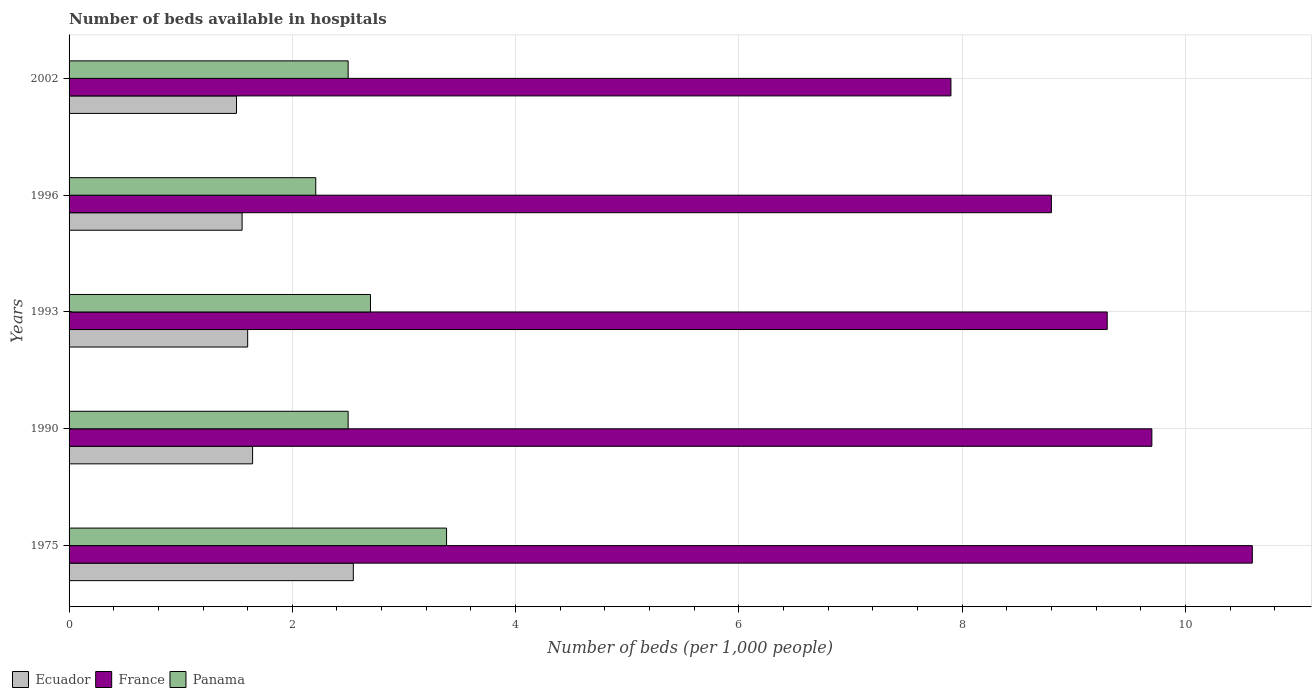How many groups of bars are there?
Ensure brevity in your answer.  5. Are the number of bars per tick equal to the number of legend labels?
Make the answer very short. Yes. How many bars are there on the 2nd tick from the top?
Your response must be concise. 3. What is the label of the 5th group of bars from the top?
Your response must be concise. 1975. In how many cases, is the number of bars for a given year not equal to the number of legend labels?
Your response must be concise. 0. What is the number of beds in the hospiatls of in France in 2002?
Make the answer very short. 7.9. Across all years, what is the maximum number of beds in the hospiatls of in France?
Offer a very short reply. 10.6. Across all years, what is the minimum number of beds in the hospiatls of in Ecuador?
Offer a very short reply. 1.5. In which year was the number of beds in the hospiatls of in Panama maximum?
Your response must be concise. 1975. What is the total number of beds in the hospiatls of in France in the graph?
Give a very brief answer. 46.3. What is the difference between the number of beds in the hospiatls of in France in 1975 and that in 1993?
Your response must be concise. 1.3. What is the difference between the number of beds in the hospiatls of in Ecuador in 1993 and the number of beds in the hospiatls of in France in 1996?
Keep it short and to the point. -7.2. What is the average number of beds in the hospiatls of in Ecuador per year?
Provide a succinct answer. 1.77. In the year 1975, what is the difference between the number of beds in the hospiatls of in Ecuador and number of beds in the hospiatls of in Panama?
Make the answer very short. -0.84. In how many years, is the number of beds in the hospiatls of in Ecuador greater than 6 ?
Your answer should be very brief. 0. What is the ratio of the number of beds in the hospiatls of in France in 1993 to that in 2002?
Provide a succinct answer. 1.18. Is the number of beds in the hospiatls of in Panama in 1990 less than that in 2002?
Make the answer very short. No. Is the difference between the number of beds in the hospiatls of in Ecuador in 1975 and 2002 greater than the difference between the number of beds in the hospiatls of in Panama in 1975 and 2002?
Provide a short and direct response. Yes. What is the difference between the highest and the second highest number of beds in the hospiatls of in France?
Provide a succinct answer. 0.9. What is the difference between the highest and the lowest number of beds in the hospiatls of in Ecuador?
Give a very brief answer. 1.05. What does the 3rd bar from the top in 1990 represents?
Your answer should be compact. Ecuador. What does the 3rd bar from the bottom in 1996 represents?
Offer a very short reply. Panama. Is it the case that in every year, the sum of the number of beds in the hospiatls of in Ecuador and number of beds in the hospiatls of in France is greater than the number of beds in the hospiatls of in Panama?
Offer a terse response. Yes. How many bars are there?
Your answer should be compact. 15. Are all the bars in the graph horizontal?
Your response must be concise. Yes. How many years are there in the graph?
Offer a terse response. 5. What is the difference between two consecutive major ticks on the X-axis?
Your answer should be very brief. 2. Where does the legend appear in the graph?
Your answer should be compact. Bottom left. What is the title of the graph?
Your answer should be very brief. Number of beds available in hospitals. Does "Seychelles" appear as one of the legend labels in the graph?
Give a very brief answer. No. What is the label or title of the X-axis?
Offer a very short reply. Number of beds (per 1,0 people). What is the label or title of the Y-axis?
Keep it short and to the point. Years. What is the Number of beds (per 1,000 people) of Ecuador in 1975?
Make the answer very short. 2.55. What is the Number of beds (per 1,000 people) of France in 1975?
Provide a succinct answer. 10.6. What is the Number of beds (per 1,000 people) of Panama in 1975?
Offer a very short reply. 3.38. What is the Number of beds (per 1,000 people) in Ecuador in 1990?
Give a very brief answer. 1.64. What is the Number of beds (per 1,000 people) of France in 1990?
Ensure brevity in your answer.  9.7. What is the Number of beds (per 1,000 people) of Ecuador in 1993?
Offer a terse response. 1.6. What is the Number of beds (per 1,000 people) of France in 1993?
Keep it short and to the point. 9.3. What is the Number of beds (per 1,000 people) in Panama in 1993?
Provide a short and direct response. 2.7. What is the Number of beds (per 1,000 people) of Ecuador in 1996?
Provide a short and direct response. 1.55. What is the Number of beds (per 1,000 people) in France in 1996?
Ensure brevity in your answer.  8.8. What is the Number of beds (per 1,000 people) of Panama in 1996?
Make the answer very short. 2.21. What is the Number of beds (per 1,000 people) in Ecuador in 2002?
Ensure brevity in your answer.  1.5. What is the Number of beds (per 1,000 people) of France in 2002?
Make the answer very short. 7.9. Across all years, what is the maximum Number of beds (per 1,000 people) in Ecuador?
Provide a short and direct response. 2.55. Across all years, what is the maximum Number of beds (per 1,000 people) of France?
Give a very brief answer. 10.6. Across all years, what is the maximum Number of beds (per 1,000 people) of Panama?
Give a very brief answer. 3.38. Across all years, what is the minimum Number of beds (per 1,000 people) in Ecuador?
Keep it short and to the point. 1.5. Across all years, what is the minimum Number of beds (per 1,000 people) of France?
Your response must be concise. 7.9. Across all years, what is the minimum Number of beds (per 1,000 people) in Panama?
Keep it short and to the point. 2.21. What is the total Number of beds (per 1,000 people) in Ecuador in the graph?
Give a very brief answer. 8.84. What is the total Number of beds (per 1,000 people) of France in the graph?
Keep it short and to the point. 46.3. What is the total Number of beds (per 1,000 people) of Panama in the graph?
Offer a very short reply. 13.29. What is the difference between the Number of beds (per 1,000 people) of Ecuador in 1975 and that in 1990?
Give a very brief answer. 0.9. What is the difference between the Number of beds (per 1,000 people) in France in 1975 and that in 1990?
Give a very brief answer. 0.9. What is the difference between the Number of beds (per 1,000 people) in Panama in 1975 and that in 1990?
Make the answer very short. 0.88. What is the difference between the Number of beds (per 1,000 people) in Ecuador in 1975 and that in 1993?
Give a very brief answer. 0.95. What is the difference between the Number of beds (per 1,000 people) in France in 1975 and that in 1993?
Ensure brevity in your answer.  1.3. What is the difference between the Number of beds (per 1,000 people) in Panama in 1975 and that in 1993?
Provide a succinct answer. 0.68. What is the difference between the Number of beds (per 1,000 people) in Ecuador in 1975 and that in 1996?
Give a very brief answer. 1. What is the difference between the Number of beds (per 1,000 people) in Panama in 1975 and that in 1996?
Offer a terse response. 1.17. What is the difference between the Number of beds (per 1,000 people) of Ecuador in 1975 and that in 2002?
Provide a short and direct response. 1.05. What is the difference between the Number of beds (per 1,000 people) in France in 1975 and that in 2002?
Ensure brevity in your answer.  2.7. What is the difference between the Number of beds (per 1,000 people) of Panama in 1975 and that in 2002?
Offer a very short reply. 0.88. What is the difference between the Number of beds (per 1,000 people) of Ecuador in 1990 and that in 1993?
Offer a very short reply. 0.04. What is the difference between the Number of beds (per 1,000 people) of Ecuador in 1990 and that in 1996?
Ensure brevity in your answer.  0.09. What is the difference between the Number of beds (per 1,000 people) of Panama in 1990 and that in 1996?
Offer a very short reply. 0.29. What is the difference between the Number of beds (per 1,000 people) of Ecuador in 1990 and that in 2002?
Offer a very short reply. 0.14. What is the difference between the Number of beds (per 1,000 people) in France in 1993 and that in 1996?
Make the answer very short. 0.5. What is the difference between the Number of beds (per 1,000 people) of Panama in 1993 and that in 1996?
Your response must be concise. 0.49. What is the difference between the Number of beds (per 1,000 people) of Ecuador in 1993 and that in 2002?
Your answer should be very brief. 0.1. What is the difference between the Number of beds (per 1,000 people) of France in 1993 and that in 2002?
Your response must be concise. 1.4. What is the difference between the Number of beds (per 1,000 people) in France in 1996 and that in 2002?
Provide a succinct answer. 0.9. What is the difference between the Number of beds (per 1,000 people) of Panama in 1996 and that in 2002?
Your answer should be very brief. -0.29. What is the difference between the Number of beds (per 1,000 people) in Ecuador in 1975 and the Number of beds (per 1,000 people) in France in 1990?
Ensure brevity in your answer.  -7.15. What is the difference between the Number of beds (per 1,000 people) of Ecuador in 1975 and the Number of beds (per 1,000 people) of Panama in 1990?
Your answer should be very brief. 0.05. What is the difference between the Number of beds (per 1,000 people) of Ecuador in 1975 and the Number of beds (per 1,000 people) of France in 1993?
Your answer should be very brief. -6.75. What is the difference between the Number of beds (per 1,000 people) of Ecuador in 1975 and the Number of beds (per 1,000 people) of Panama in 1993?
Give a very brief answer. -0.15. What is the difference between the Number of beds (per 1,000 people) in France in 1975 and the Number of beds (per 1,000 people) in Panama in 1993?
Give a very brief answer. 7.9. What is the difference between the Number of beds (per 1,000 people) in Ecuador in 1975 and the Number of beds (per 1,000 people) in France in 1996?
Offer a terse response. -6.25. What is the difference between the Number of beds (per 1,000 people) of Ecuador in 1975 and the Number of beds (per 1,000 people) of Panama in 1996?
Make the answer very short. 0.34. What is the difference between the Number of beds (per 1,000 people) of France in 1975 and the Number of beds (per 1,000 people) of Panama in 1996?
Your response must be concise. 8.39. What is the difference between the Number of beds (per 1,000 people) in Ecuador in 1975 and the Number of beds (per 1,000 people) in France in 2002?
Provide a short and direct response. -5.35. What is the difference between the Number of beds (per 1,000 people) in Ecuador in 1975 and the Number of beds (per 1,000 people) in Panama in 2002?
Your answer should be very brief. 0.05. What is the difference between the Number of beds (per 1,000 people) of Ecuador in 1990 and the Number of beds (per 1,000 people) of France in 1993?
Provide a short and direct response. -7.66. What is the difference between the Number of beds (per 1,000 people) of Ecuador in 1990 and the Number of beds (per 1,000 people) of Panama in 1993?
Offer a terse response. -1.06. What is the difference between the Number of beds (per 1,000 people) of France in 1990 and the Number of beds (per 1,000 people) of Panama in 1993?
Give a very brief answer. 7. What is the difference between the Number of beds (per 1,000 people) of Ecuador in 1990 and the Number of beds (per 1,000 people) of France in 1996?
Your answer should be very brief. -7.16. What is the difference between the Number of beds (per 1,000 people) in Ecuador in 1990 and the Number of beds (per 1,000 people) in Panama in 1996?
Your answer should be very brief. -0.57. What is the difference between the Number of beds (per 1,000 people) in France in 1990 and the Number of beds (per 1,000 people) in Panama in 1996?
Your answer should be compact. 7.49. What is the difference between the Number of beds (per 1,000 people) of Ecuador in 1990 and the Number of beds (per 1,000 people) of France in 2002?
Ensure brevity in your answer.  -6.26. What is the difference between the Number of beds (per 1,000 people) of Ecuador in 1990 and the Number of beds (per 1,000 people) of Panama in 2002?
Offer a very short reply. -0.86. What is the difference between the Number of beds (per 1,000 people) in Ecuador in 1993 and the Number of beds (per 1,000 people) in Panama in 1996?
Keep it short and to the point. -0.61. What is the difference between the Number of beds (per 1,000 people) in France in 1993 and the Number of beds (per 1,000 people) in Panama in 1996?
Your response must be concise. 7.09. What is the difference between the Number of beds (per 1,000 people) in France in 1993 and the Number of beds (per 1,000 people) in Panama in 2002?
Give a very brief answer. 6.8. What is the difference between the Number of beds (per 1,000 people) of Ecuador in 1996 and the Number of beds (per 1,000 people) of France in 2002?
Offer a terse response. -6.35. What is the difference between the Number of beds (per 1,000 people) of Ecuador in 1996 and the Number of beds (per 1,000 people) of Panama in 2002?
Keep it short and to the point. -0.95. What is the difference between the Number of beds (per 1,000 people) in France in 1996 and the Number of beds (per 1,000 people) in Panama in 2002?
Your answer should be compact. 6.3. What is the average Number of beds (per 1,000 people) in Ecuador per year?
Give a very brief answer. 1.77. What is the average Number of beds (per 1,000 people) in France per year?
Provide a succinct answer. 9.26. What is the average Number of beds (per 1,000 people) in Panama per year?
Offer a terse response. 2.66. In the year 1975, what is the difference between the Number of beds (per 1,000 people) in Ecuador and Number of beds (per 1,000 people) in France?
Provide a succinct answer. -8.05. In the year 1975, what is the difference between the Number of beds (per 1,000 people) of Ecuador and Number of beds (per 1,000 people) of Panama?
Your response must be concise. -0.84. In the year 1975, what is the difference between the Number of beds (per 1,000 people) in France and Number of beds (per 1,000 people) in Panama?
Your response must be concise. 7.22. In the year 1990, what is the difference between the Number of beds (per 1,000 people) in Ecuador and Number of beds (per 1,000 people) in France?
Provide a succinct answer. -8.06. In the year 1990, what is the difference between the Number of beds (per 1,000 people) in Ecuador and Number of beds (per 1,000 people) in Panama?
Provide a short and direct response. -0.86. In the year 1990, what is the difference between the Number of beds (per 1,000 people) of France and Number of beds (per 1,000 people) of Panama?
Provide a short and direct response. 7.2. In the year 1993, what is the difference between the Number of beds (per 1,000 people) of France and Number of beds (per 1,000 people) of Panama?
Make the answer very short. 6.6. In the year 1996, what is the difference between the Number of beds (per 1,000 people) of Ecuador and Number of beds (per 1,000 people) of France?
Keep it short and to the point. -7.25. In the year 1996, what is the difference between the Number of beds (per 1,000 people) in Ecuador and Number of beds (per 1,000 people) in Panama?
Your response must be concise. -0.66. In the year 1996, what is the difference between the Number of beds (per 1,000 people) in France and Number of beds (per 1,000 people) in Panama?
Ensure brevity in your answer.  6.59. In the year 2002, what is the difference between the Number of beds (per 1,000 people) of Ecuador and Number of beds (per 1,000 people) of Panama?
Your response must be concise. -1. What is the ratio of the Number of beds (per 1,000 people) in Ecuador in 1975 to that in 1990?
Ensure brevity in your answer.  1.55. What is the ratio of the Number of beds (per 1,000 people) of France in 1975 to that in 1990?
Your answer should be very brief. 1.09. What is the ratio of the Number of beds (per 1,000 people) of Panama in 1975 to that in 1990?
Provide a succinct answer. 1.35. What is the ratio of the Number of beds (per 1,000 people) of Ecuador in 1975 to that in 1993?
Your answer should be compact. 1.59. What is the ratio of the Number of beds (per 1,000 people) of France in 1975 to that in 1993?
Keep it short and to the point. 1.14. What is the ratio of the Number of beds (per 1,000 people) of Panama in 1975 to that in 1993?
Make the answer very short. 1.25. What is the ratio of the Number of beds (per 1,000 people) of Ecuador in 1975 to that in 1996?
Your answer should be very brief. 1.64. What is the ratio of the Number of beds (per 1,000 people) in France in 1975 to that in 1996?
Your answer should be very brief. 1.2. What is the ratio of the Number of beds (per 1,000 people) in Panama in 1975 to that in 1996?
Offer a very short reply. 1.53. What is the ratio of the Number of beds (per 1,000 people) of Ecuador in 1975 to that in 2002?
Offer a very short reply. 1.7. What is the ratio of the Number of beds (per 1,000 people) in France in 1975 to that in 2002?
Your answer should be compact. 1.34. What is the ratio of the Number of beds (per 1,000 people) of Panama in 1975 to that in 2002?
Offer a terse response. 1.35. What is the ratio of the Number of beds (per 1,000 people) of Ecuador in 1990 to that in 1993?
Provide a succinct answer. 1.03. What is the ratio of the Number of beds (per 1,000 people) in France in 1990 to that in 1993?
Offer a very short reply. 1.04. What is the ratio of the Number of beds (per 1,000 people) of Panama in 1990 to that in 1993?
Provide a succinct answer. 0.93. What is the ratio of the Number of beds (per 1,000 people) of Ecuador in 1990 to that in 1996?
Your answer should be compact. 1.06. What is the ratio of the Number of beds (per 1,000 people) in France in 1990 to that in 1996?
Make the answer very short. 1.1. What is the ratio of the Number of beds (per 1,000 people) in Panama in 1990 to that in 1996?
Your response must be concise. 1.13. What is the ratio of the Number of beds (per 1,000 people) of Ecuador in 1990 to that in 2002?
Ensure brevity in your answer.  1.1. What is the ratio of the Number of beds (per 1,000 people) of France in 1990 to that in 2002?
Provide a short and direct response. 1.23. What is the ratio of the Number of beds (per 1,000 people) in Ecuador in 1993 to that in 1996?
Offer a terse response. 1.03. What is the ratio of the Number of beds (per 1,000 people) of France in 1993 to that in 1996?
Your answer should be very brief. 1.06. What is the ratio of the Number of beds (per 1,000 people) of Panama in 1993 to that in 1996?
Keep it short and to the point. 1.22. What is the ratio of the Number of beds (per 1,000 people) of Ecuador in 1993 to that in 2002?
Offer a terse response. 1.07. What is the ratio of the Number of beds (per 1,000 people) in France in 1993 to that in 2002?
Your answer should be very brief. 1.18. What is the ratio of the Number of beds (per 1,000 people) of Panama in 1993 to that in 2002?
Make the answer very short. 1.08. What is the ratio of the Number of beds (per 1,000 people) of Ecuador in 1996 to that in 2002?
Ensure brevity in your answer.  1.03. What is the ratio of the Number of beds (per 1,000 people) in France in 1996 to that in 2002?
Provide a succinct answer. 1.11. What is the ratio of the Number of beds (per 1,000 people) in Panama in 1996 to that in 2002?
Provide a short and direct response. 0.88. What is the difference between the highest and the second highest Number of beds (per 1,000 people) of Ecuador?
Offer a very short reply. 0.9. What is the difference between the highest and the second highest Number of beds (per 1,000 people) in Panama?
Provide a short and direct response. 0.68. What is the difference between the highest and the lowest Number of beds (per 1,000 people) of Ecuador?
Your answer should be compact. 1.05. What is the difference between the highest and the lowest Number of beds (per 1,000 people) in France?
Offer a terse response. 2.7. What is the difference between the highest and the lowest Number of beds (per 1,000 people) of Panama?
Provide a short and direct response. 1.17. 